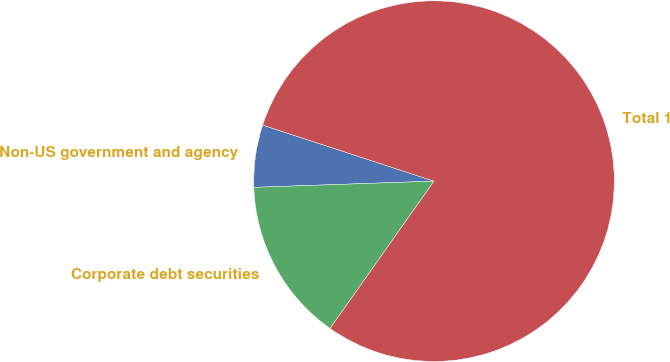<chart> <loc_0><loc_0><loc_500><loc_500><pie_chart><fcel>Non-US government and agency<fcel>Corporate debt securities<fcel>Total 1<nl><fcel>5.58%<fcel>14.67%<fcel>79.75%<nl></chart> 